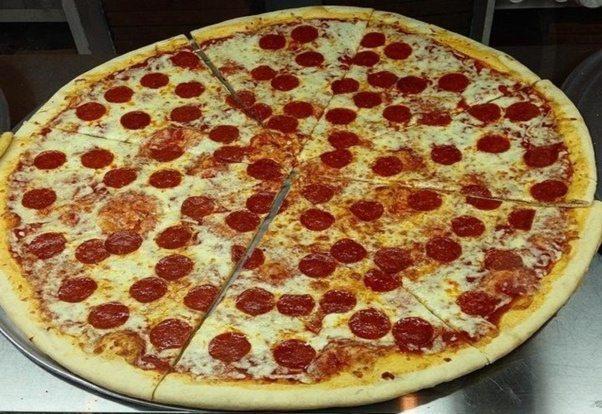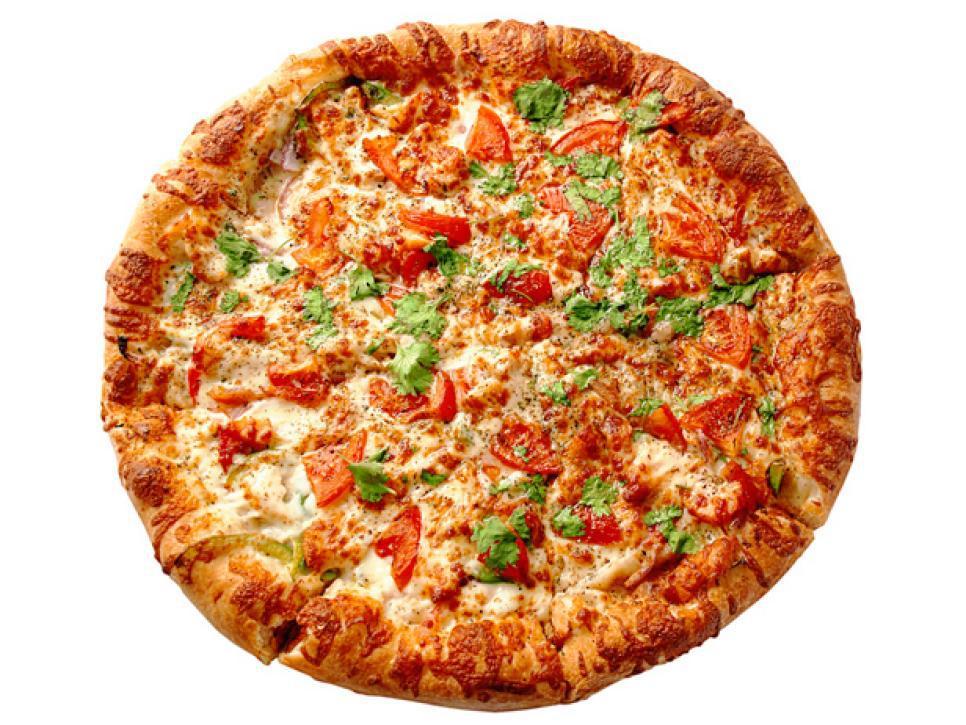The first image is the image on the left, the second image is the image on the right. Given the left and right images, does the statement "A slice is being lifted off a pizza." hold true? Answer yes or no. No. The first image is the image on the left, the second image is the image on the right. For the images shown, is this caption "A slice is being taken out of a pizza in the right image, with the cheese oozing down." true? Answer yes or no. No. 